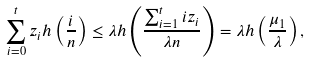<formula> <loc_0><loc_0><loc_500><loc_500>\sum _ { i = 0 } ^ { t } z _ { i } h \left ( \frac { i } { n } \right ) \leq \lambda h \left ( \frac { \sum _ { i = 1 } ^ { t } i z _ { i } } { \lambda n } \right ) = \lambda h \left ( \frac { \mu _ { 1 } } { \lambda } \right ) ,</formula> 